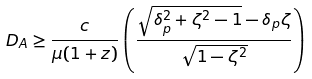<formula> <loc_0><loc_0><loc_500><loc_500>D _ { A } \geq \frac { c } { \mu ( 1 + z ) } \left ( \frac { \sqrt { \delta _ { p } ^ { 2 } + \zeta ^ { 2 } - 1 } - \delta _ { p } \zeta } { \sqrt { 1 - \zeta ^ { 2 } } } \right )</formula> 